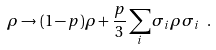Convert formula to latex. <formula><loc_0><loc_0><loc_500><loc_500>\rho \rightarrow ( 1 - p ) \rho + \frac { p } { 3 } \sum _ { i } \sigma _ { i } \rho \sigma _ { i } \ .</formula> 